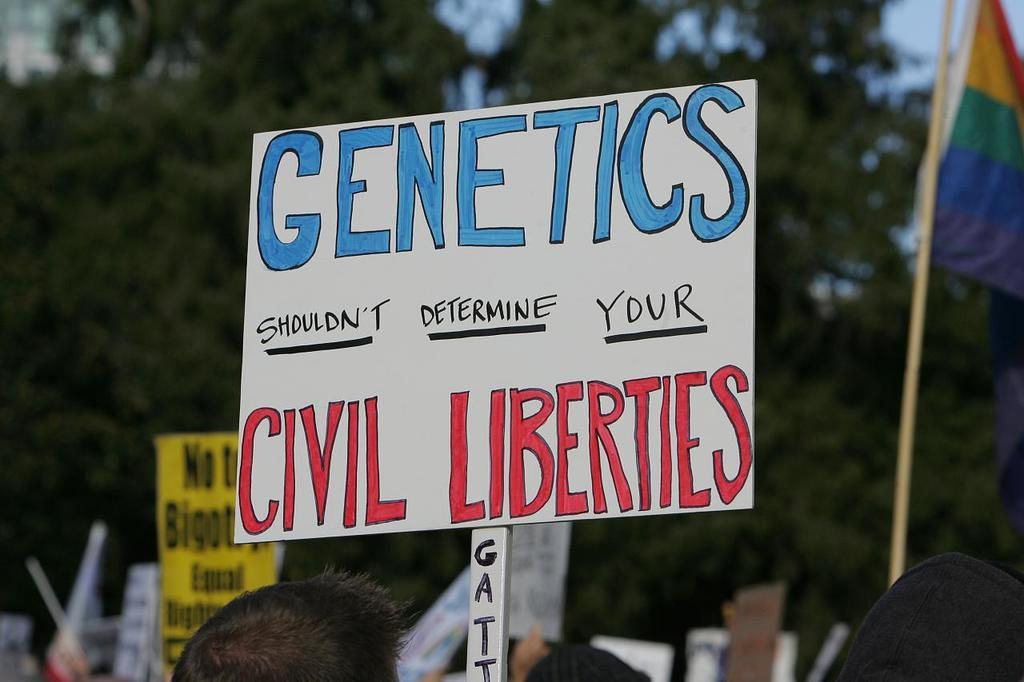What is the main object in the image? There is a white color board in the image. What message is written on the board? The text "GENETICS SHOULDN'T DETERMINE YOUR CIVIL LIBERTIES" is written on the board. What can be seen in the background of the image? There are green color trees in the background of the image. How many people are in the crowd shown in the image? There is no crowd present in the image; it features a white color board with text and green color trees in the background. What emotion does the person in the image display? There is no person present in the image; it features a white color board with text and green color trees in the background. 